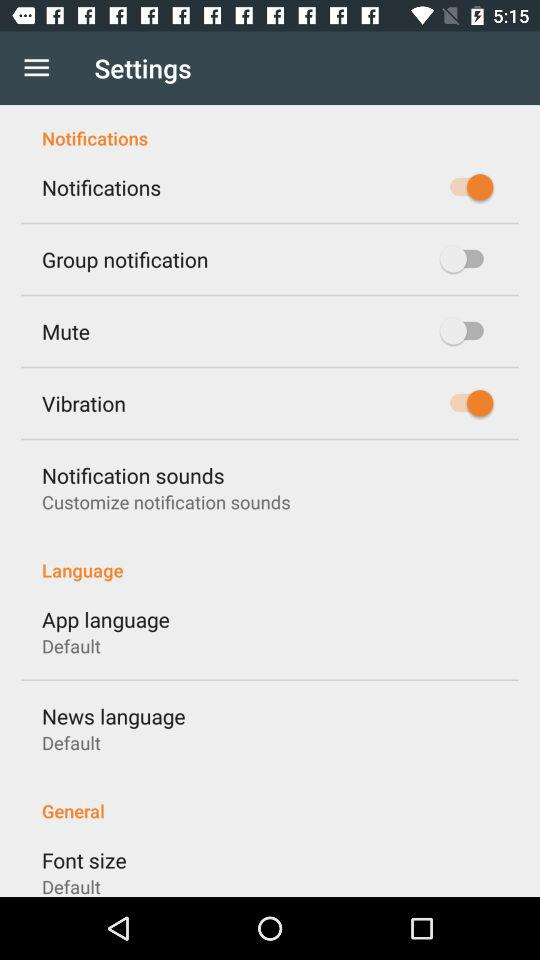What is the selected font size? The selected font size is "Default". 